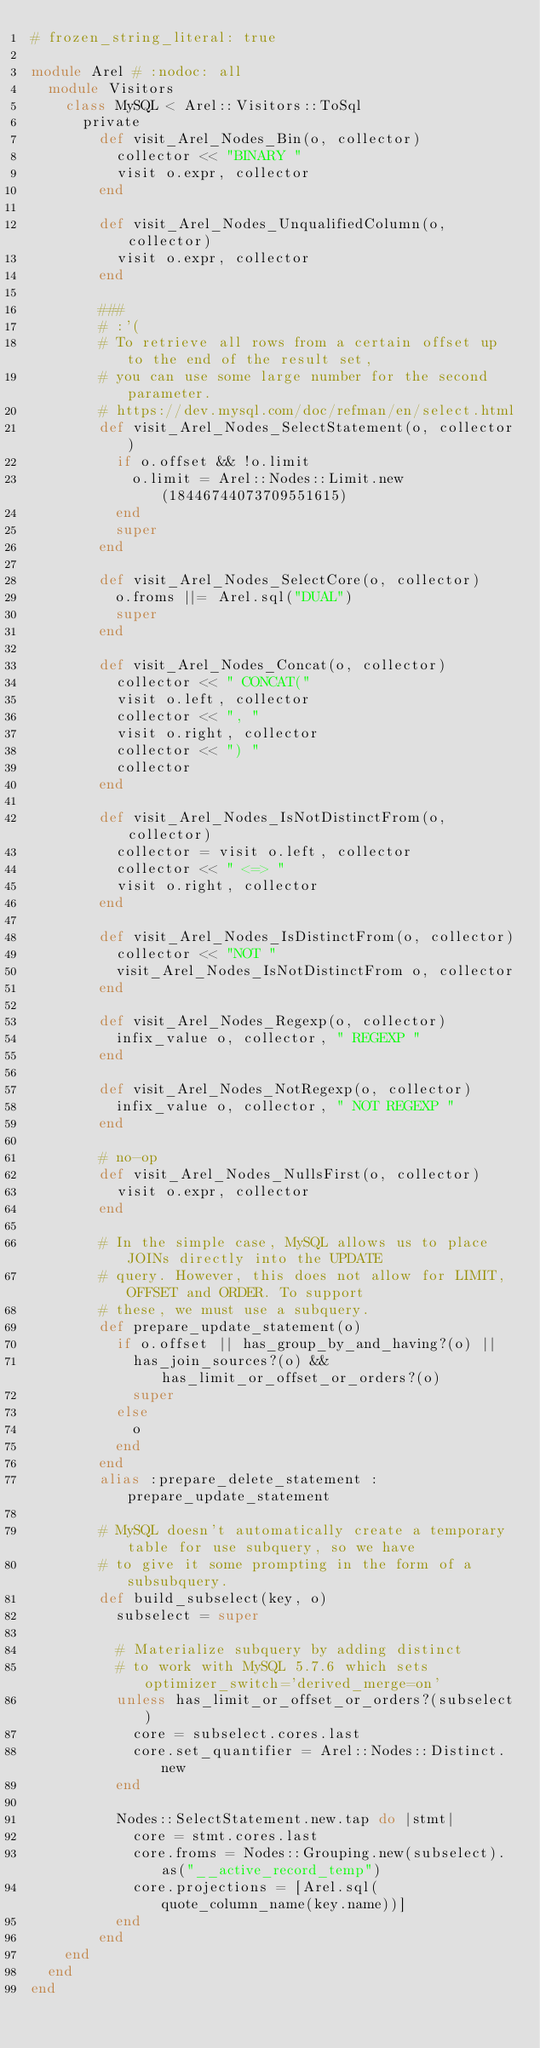<code> <loc_0><loc_0><loc_500><loc_500><_Ruby_># frozen_string_literal: true

module Arel # :nodoc: all
  module Visitors
    class MySQL < Arel::Visitors::ToSql
      private
        def visit_Arel_Nodes_Bin(o, collector)
          collector << "BINARY "
          visit o.expr, collector
        end

        def visit_Arel_Nodes_UnqualifiedColumn(o, collector)
          visit o.expr, collector
        end

        ###
        # :'(
        # To retrieve all rows from a certain offset up to the end of the result set,
        # you can use some large number for the second parameter.
        # https://dev.mysql.com/doc/refman/en/select.html
        def visit_Arel_Nodes_SelectStatement(o, collector)
          if o.offset && !o.limit
            o.limit = Arel::Nodes::Limit.new(18446744073709551615)
          end
          super
        end

        def visit_Arel_Nodes_SelectCore(o, collector)
          o.froms ||= Arel.sql("DUAL")
          super
        end

        def visit_Arel_Nodes_Concat(o, collector)
          collector << " CONCAT("
          visit o.left, collector
          collector << ", "
          visit o.right, collector
          collector << ") "
          collector
        end

        def visit_Arel_Nodes_IsNotDistinctFrom(o, collector)
          collector = visit o.left, collector
          collector << " <=> "
          visit o.right, collector
        end

        def visit_Arel_Nodes_IsDistinctFrom(o, collector)
          collector << "NOT "
          visit_Arel_Nodes_IsNotDistinctFrom o, collector
        end

        def visit_Arel_Nodes_Regexp(o, collector)
          infix_value o, collector, " REGEXP "
        end

        def visit_Arel_Nodes_NotRegexp(o, collector)
          infix_value o, collector, " NOT REGEXP "
        end

        # no-op
        def visit_Arel_Nodes_NullsFirst(o, collector)
          visit o.expr, collector
        end

        # In the simple case, MySQL allows us to place JOINs directly into the UPDATE
        # query. However, this does not allow for LIMIT, OFFSET and ORDER. To support
        # these, we must use a subquery.
        def prepare_update_statement(o)
          if o.offset || has_group_by_and_having?(o) ||
            has_join_sources?(o) && has_limit_or_offset_or_orders?(o)
            super
          else
            o
          end
        end
        alias :prepare_delete_statement :prepare_update_statement

        # MySQL doesn't automatically create a temporary table for use subquery, so we have
        # to give it some prompting in the form of a subsubquery.
        def build_subselect(key, o)
          subselect = super

          # Materialize subquery by adding distinct
          # to work with MySQL 5.7.6 which sets optimizer_switch='derived_merge=on'
          unless has_limit_or_offset_or_orders?(subselect)
            core = subselect.cores.last
            core.set_quantifier = Arel::Nodes::Distinct.new
          end

          Nodes::SelectStatement.new.tap do |stmt|
            core = stmt.cores.last
            core.froms = Nodes::Grouping.new(subselect).as("__active_record_temp")
            core.projections = [Arel.sql(quote_column_name(key.name))]
          end
        end
    end
  end
end
</code> 